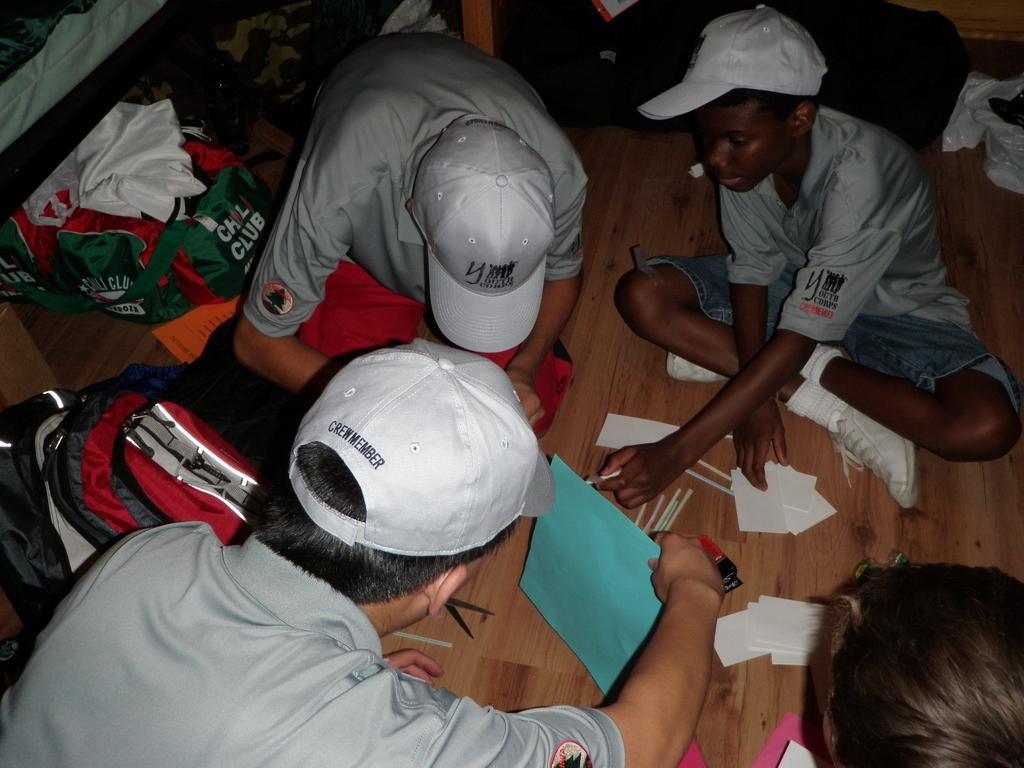How would you summarize this image in a sentence or two? In the image i can see a three persons wearing a caps and sitting on the floor. Besides them there are two bags and in front of them there is the one person who is sitting. 